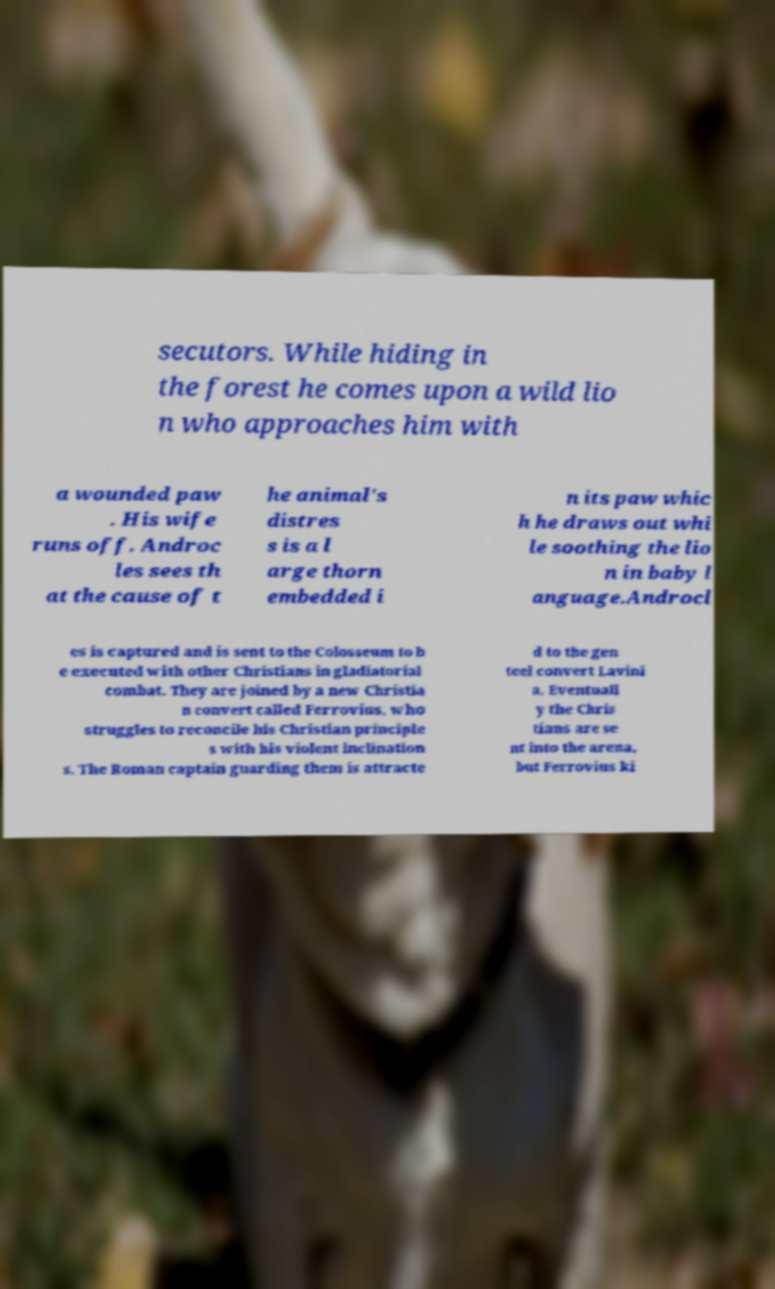Can you accurately transcribe the text from the provided image for me? secutors. While hiding in the forest he comes upon a wild lio n who approaches him with a wounded paw . His wife runs off. Androc les sees th at the cause of t he animal's distres s is a l arge thorn embedded i n its paw whic h he draws out whi le soothing the lio n in baby l anguage.Androcl es is captured and is sent to the Colosseum to b e executed with other Christians in gladiatorial combat. They are joined by a new Christia n convert called Ferrovius, who struggles to reconcile his Christian principle s with his violent inclination s. The Roman captain guarding them is attracte d to the gen teel convert Lavini a. Eventuall y the Chris tians are se nt into the arena, but Ferrovius ki 